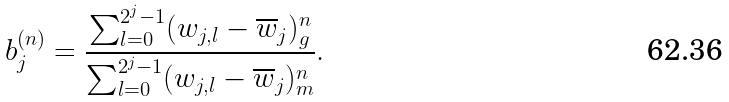<formula> <loc_0><loc_0><loc_500><loc_500>b ^ { ( n ) } _ { j } = \frac { \sum _ { l = 0 } ^ { 2 ^ { j } - 1 } ( w _ { j , l } - \overline { w } _ { j } ) ^ { n } _ { g } } { \sum _ { l = 0 } ^ { 2 ^ { j } - 1 } ( w _ { j , l } - \overline { w } _ { j } ) ^ { n } _ { m } } .</formula> 